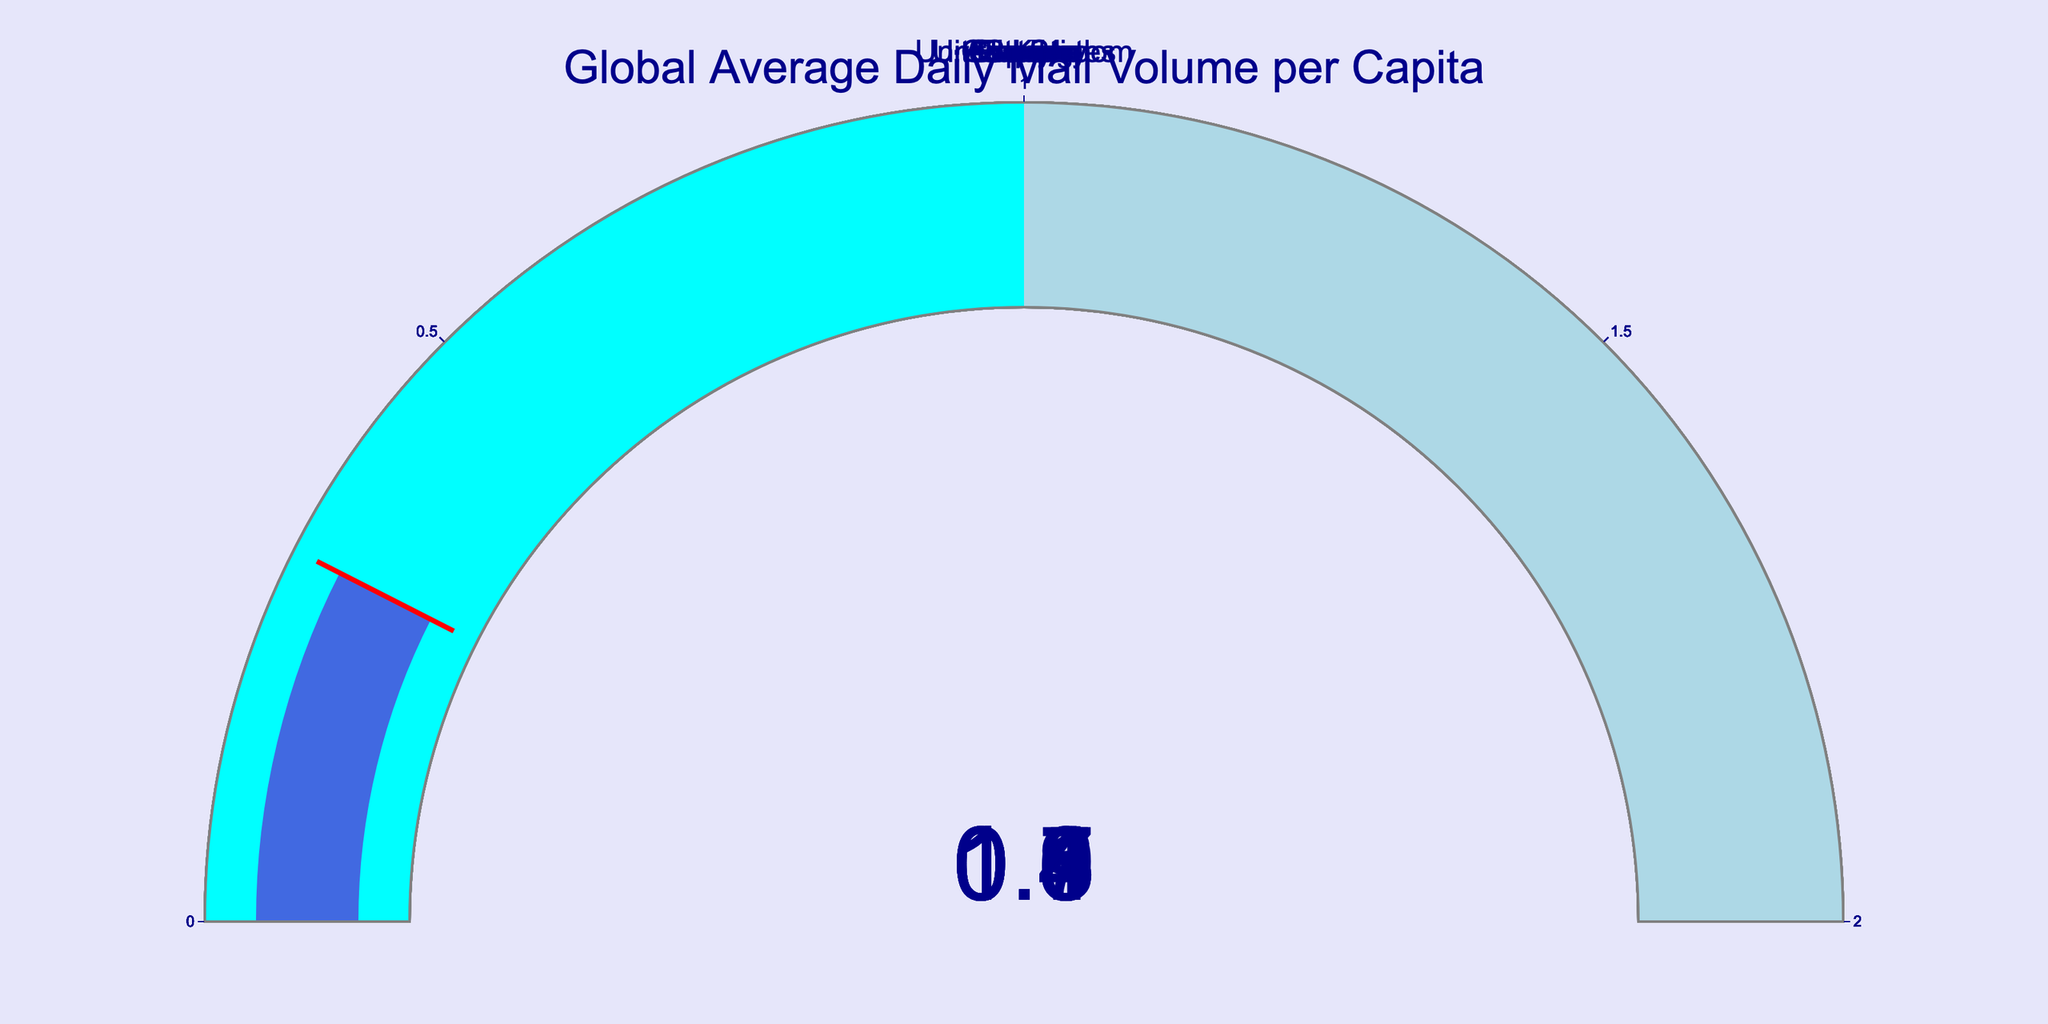what is the title of the figure? The title of the figure is located at the top center, and it should be directly stated there.
Answer: Global Average Daily Mail Volume per Capita How many countries are represented in the figure? By counting the number of gauge indicators shown in the figure, you can determine the number of countries.
Answer: 10 Which country has the highest average daily mail volume per capita? Look at the values displayed on each gauge and identify the maximum value.
Answer: United States (1.8) Which country has the lowest average daily mail volume per capita? Look at the values displayed on each gauge and identify the minimum value.
Answer: Spain (0.3) What is the sum of the average daily mail volume per capita for Australia and Canada? Add the values for Australia (0.7) and Canada (0.9).
Answer: 1.6 How many countries have an average daily mail volume per capita of 1 or more? Count the countries whose gauge indicators show values greater than or equal to 1.
Answer: 4 Is the average daily mail volume per capita of Germany greater than that of the United Kingdom? Compare the values for Germany (1.3) and United Kingdom (1.1).
Answer: Yes (Germany: 1.3 > UK: 1.1) What is the average daily mail volume per capita among France, Sweden, and Italy? Sum the values for France (0.6), Sweden (0.5), and Italy (0.4), then divide by 3.
Answer: 0.5 Which countries' average daily mail volumes per capita fall under the threshold indicated by the red line? Identify the countries whose values on the gauge are lower than their respective red thresholds.
Answer: None Are there more countries with a daily mail volume per capita above or below 1? Count the number of countries with values above 1 and below 1 and compare.
Answer: Below (6 below, 4 above) 